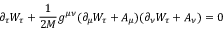Convert formula to latex. <formula><loc_0><loc_0><loc_500><loc_500>\partial _ { \tau } W _ { \tau } + \frac { 1 } { 2 M } g ^ { \mu \nu } ( \partial _ { \mu } W _ { \tau } + A _ { \mu } ) ( \partial _ { \nu } W _ { \tau } + A _ { \nu } ) = 0</formula> 